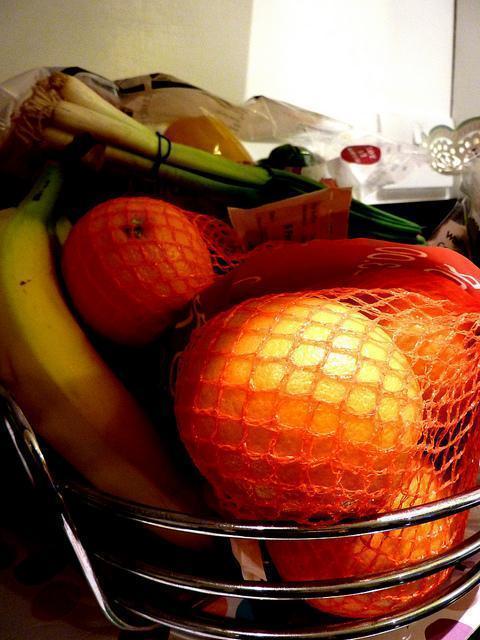What vegetable is bundled together?
From the following set of four choices, select the accurate answer to respond to the question.
Options: Asparagus, broccoli, celery, onion. Onion. 